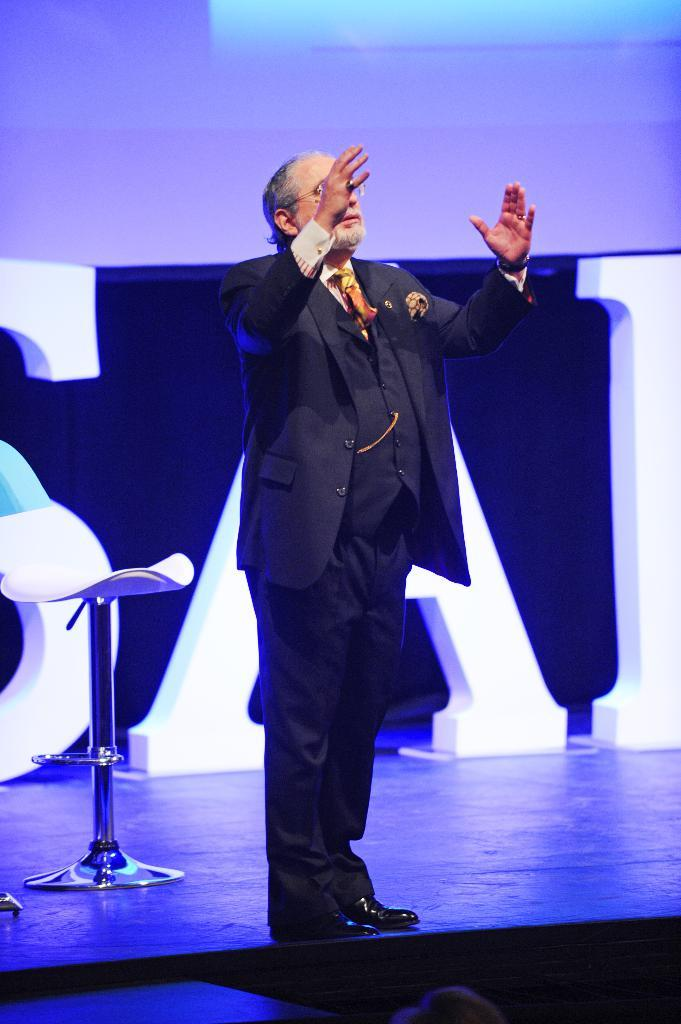What is the person in the image doing? The person is standing on a stage. Can you describe the setting of the image? The person is standing on a stage, and there is a chair behind them. What type of silk material is used to make the zipper on the person's clothing in the image? There is no mention of zippers or silk material in the image, so this information cannot be determined. 